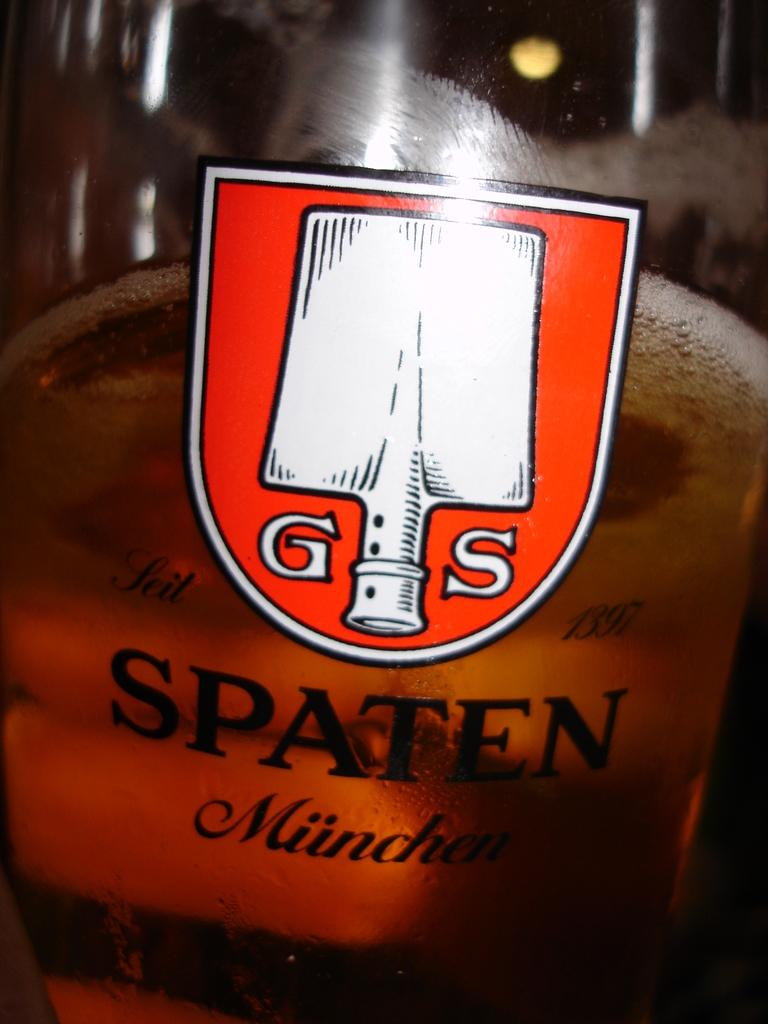<image>
Offer a succinct explanation of the picture presented. A bottle of Spaten Munchen beer with G S logo 